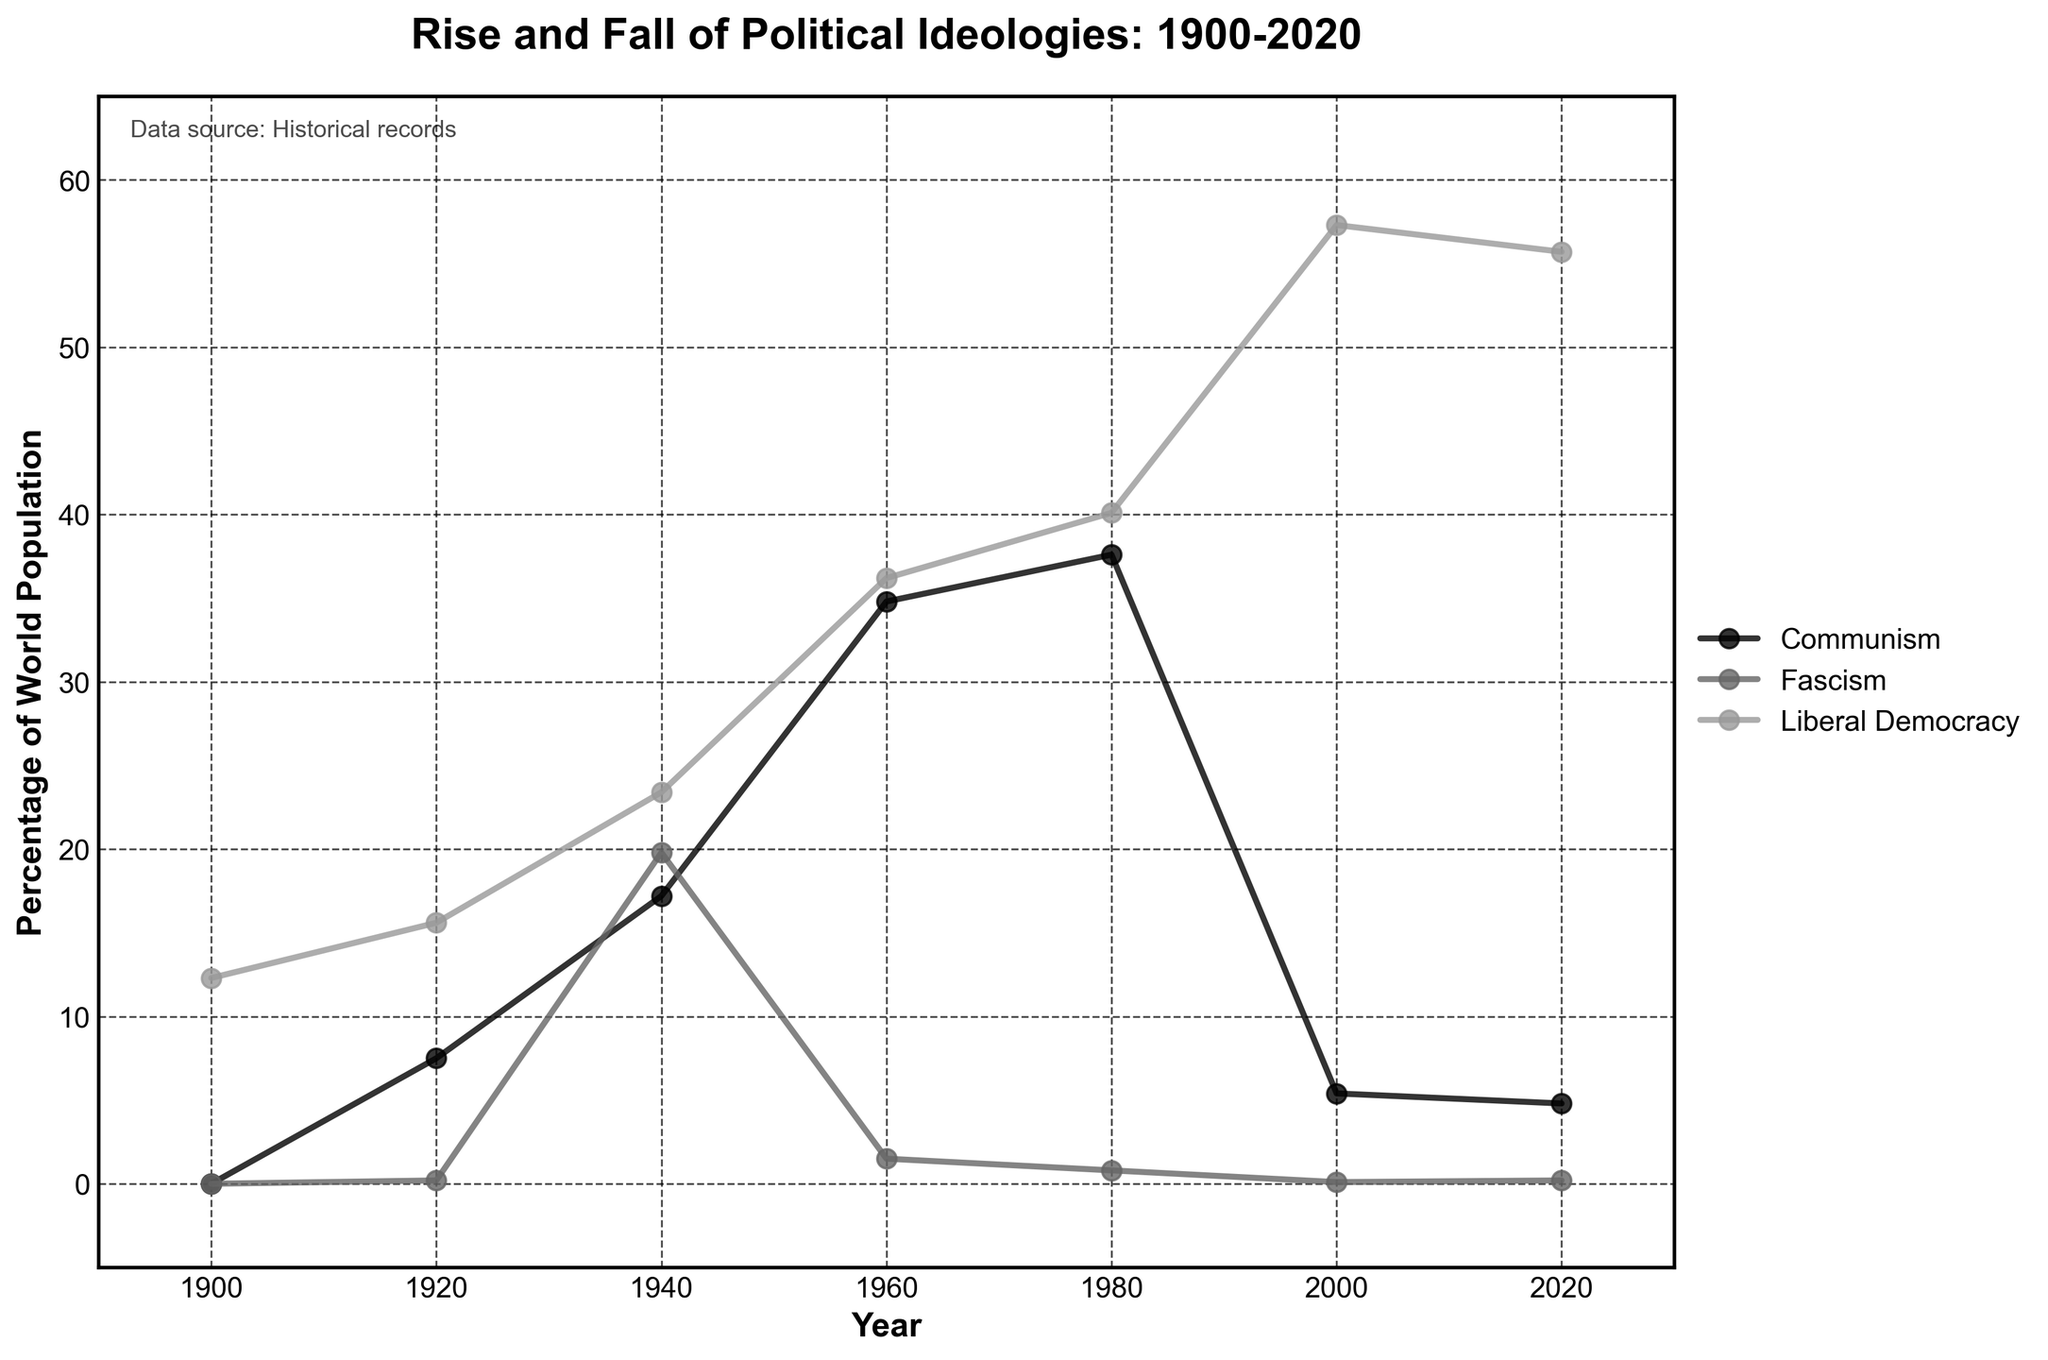What is the percentage of the world population living under Liberal Democracy in 2000? In 2000, the graph shows the percentage of the world population living under Liberal Democracy is marked, corresponding to a value on the y-axis.
Answer: 57.3% How did the percentage of the world population living under Fascism change between 1940 and 1960? In 1940, the percentage was 19.8% and in 1960 it was 1.5%. To find the change, subtract the 1960 value from the 1940 value (19.8 - 1.5).
Answer: -18.3% Which political ideology had the highest percentage of the world population in 2020? In 2020, compare the y-values of Communism, Fascism, and Liberal Democracy. Liberal Democracy has the highest percentage.
Answer: Liberal Democracy Between which years did Communism see the biggest increase? By observing the changes in the graph for Communism, the biggest increase is from 1920 (7.5%) to 1940 (17.2%). To confirm, subtract 7.5 from 17.2.
Answer: 1920 to 1940 In which year did Liberal Democracy surpass 50% of the world population for the first time? Looking at the curve for Liberal Democracy, it surpasses the 50% mark between the 1980s and 2000s. Specifically, it is above 50% in the year 2000.
Answer: 2000 Compare the trends for Communism and Liberal Democracy between 1980 and 2000. From 1980 to 2000, Communism declined from 37.6% to 5.4%, while Liberal Democracy increased from 40.1% to 57.3%.
Answer: Communism decreased, Liberal Democracy increased What was the combined percentage of the world population living under Fascism and Communism in 1940? In 1940, Fascism was at 19.8% and Communism was at 17.2%. Their combined percentage is 19.8 + 17.2.
Answer: 37% What trend can be observed for Fascism from 1920 to 2000? Fascism shows a peak in 1940 at 19.8% and then dramatically reduces to near zero by 2000.
Answer: Decrease to near zero What is the trend for Liberal Democracy from 1900 to 2020? The trend for Liberal Democracy shows a steady increase from 12.3% in 1900 to 57.3% in 2000, with a slight decrease to 55.7% in 2020.
Answer: Increasing with a slight recent decrease 